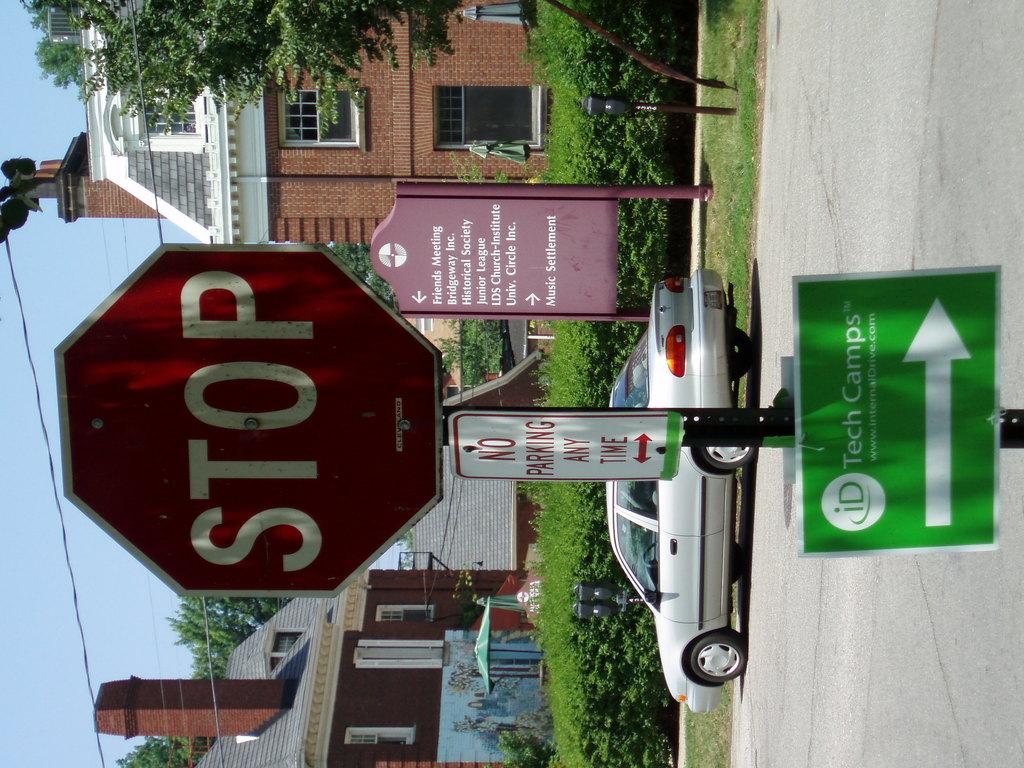What does the sign say?
Make the answer very short. Stop. What is not allowed at any time?
Your answer should be compact. Parking. 